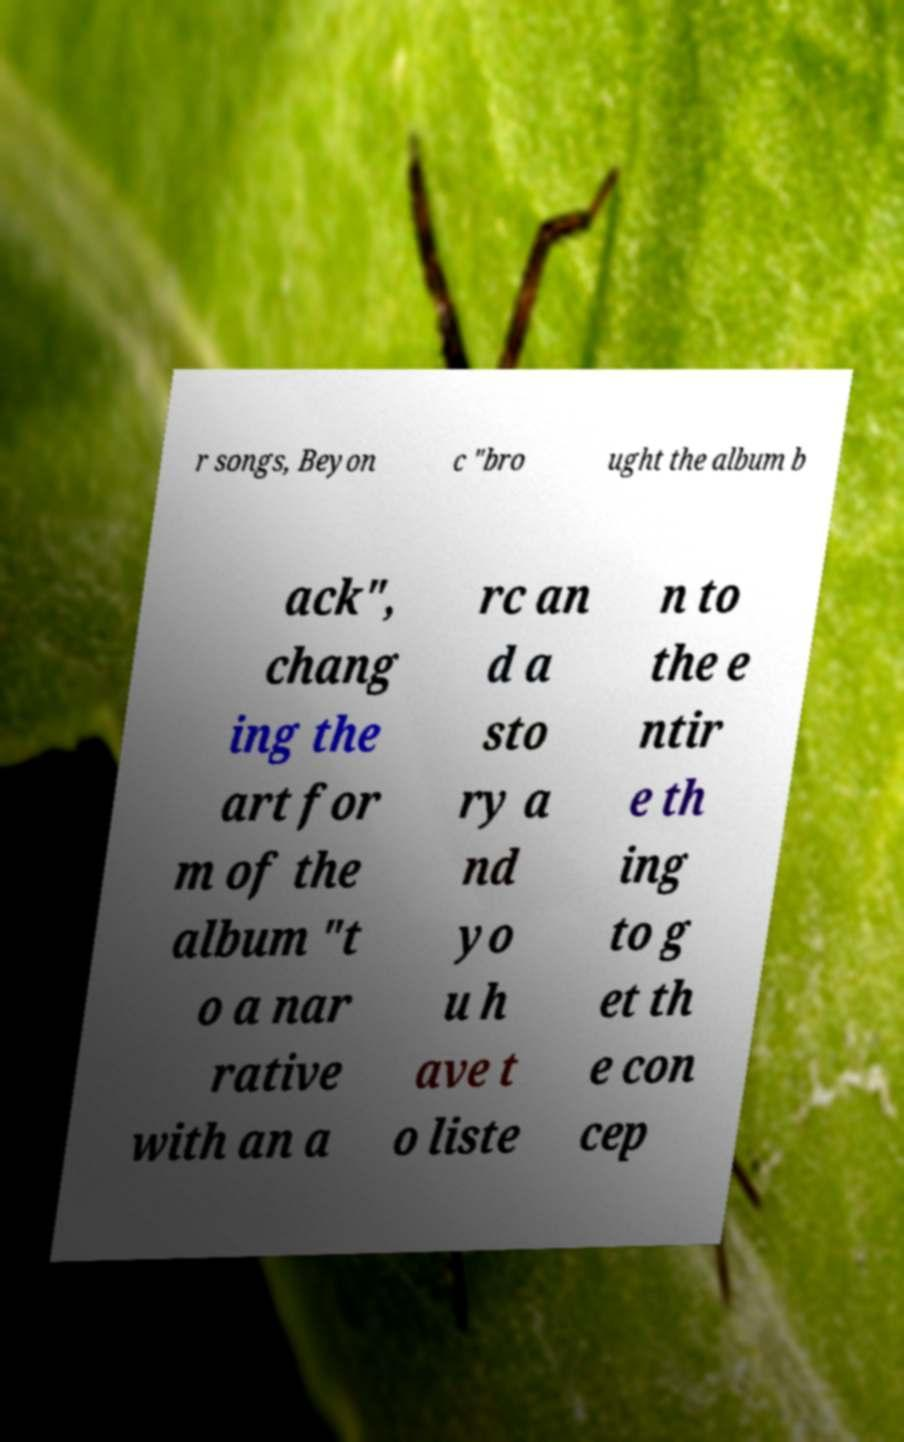For documentation purposes, I need the text within this image transcribed. Could you provide that? r songs, Beyon c "bro ught the album b ack", chang ing the art for m of the album "t o a nar rative with an a rc an d a sto ry a nd yo u h ave t o liste n to the e ntir e th ing to g et th e con cep 